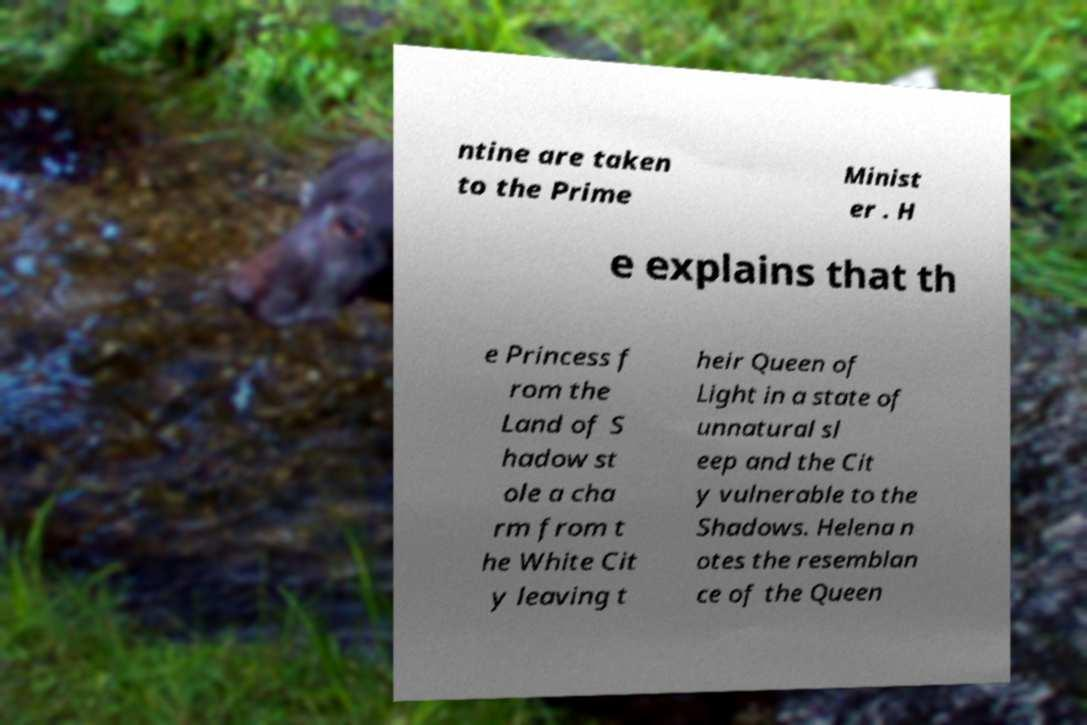Please identify and transcribe the text found in this image. ntine are taken to the Prime Minist er . H e explains that th e Princess f rom the Land of S hadow st ole a cha rm from t he White Cit y leaving t heir Queen of Light in a state of unnatural sl eep and the Cit y vulnerable to the Shadows. Helena n otes the resemblan ce of the Queen 